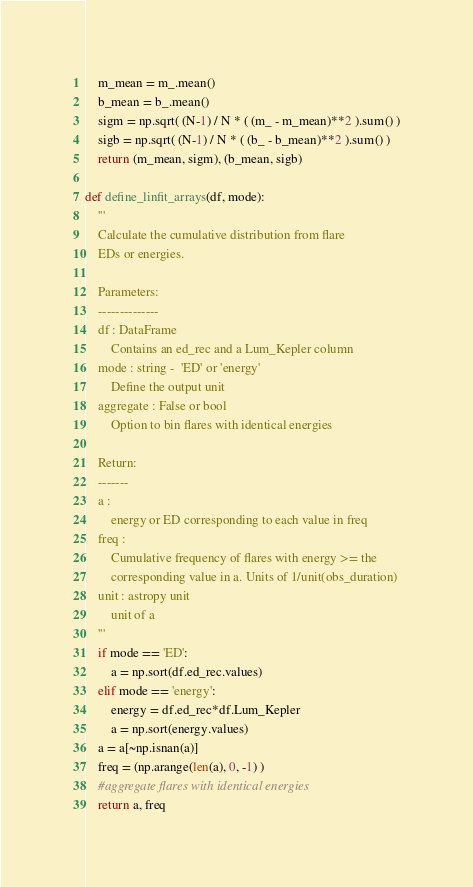<code> <loc_0><loc_0><loc_500><loc_500><_Python_>    m_mean = m_.mean()
    b_mean = b_.mean()
    sigm = np.sqrt( (N-1) / N * ( (m_ - m_mean)**2 ).sum() )
    sigb = np.sqrt( (N-1) / N * ( (b_ - b_mean)**2 ).sum() )
    return (m_mean, sigm), (b_mean, sigb)

def define_linfit_arrays(df, mode):
    '''
    Calculate the cumulative distribution from flare
    EDs or energies.

    Parameters:
    --------------
    df : DataFrame
        Contains an ed_rec and a Lum_Kepler column
    mode : string -  'ED' or 'energy'
        Define the output unit
    aggregate : False or bool
        Option to bin flares with identical energies

    Return:
    -------
    a :
        energy or ED corresponding to each value in freq
    freq :
        Cumulative frequency of flares with energy >= the
        corresponding value in a. Units of 1/unit(obs_duration)
    unit : astropy unit
        unit of a
    '''
    if mode == 'ED':
        a = np.sort(df.ed_rec.values)
    elif mode == 'energy':
        energy = df.ed_rec*df.Lum_Kepler
        a = np.sort(energy.values)
    a = a[~np.isnan(a)]
    freq = (np.arange(len(a), 0, -1) )
    #aggregate flares with identical energies
    return a, freq</code> 